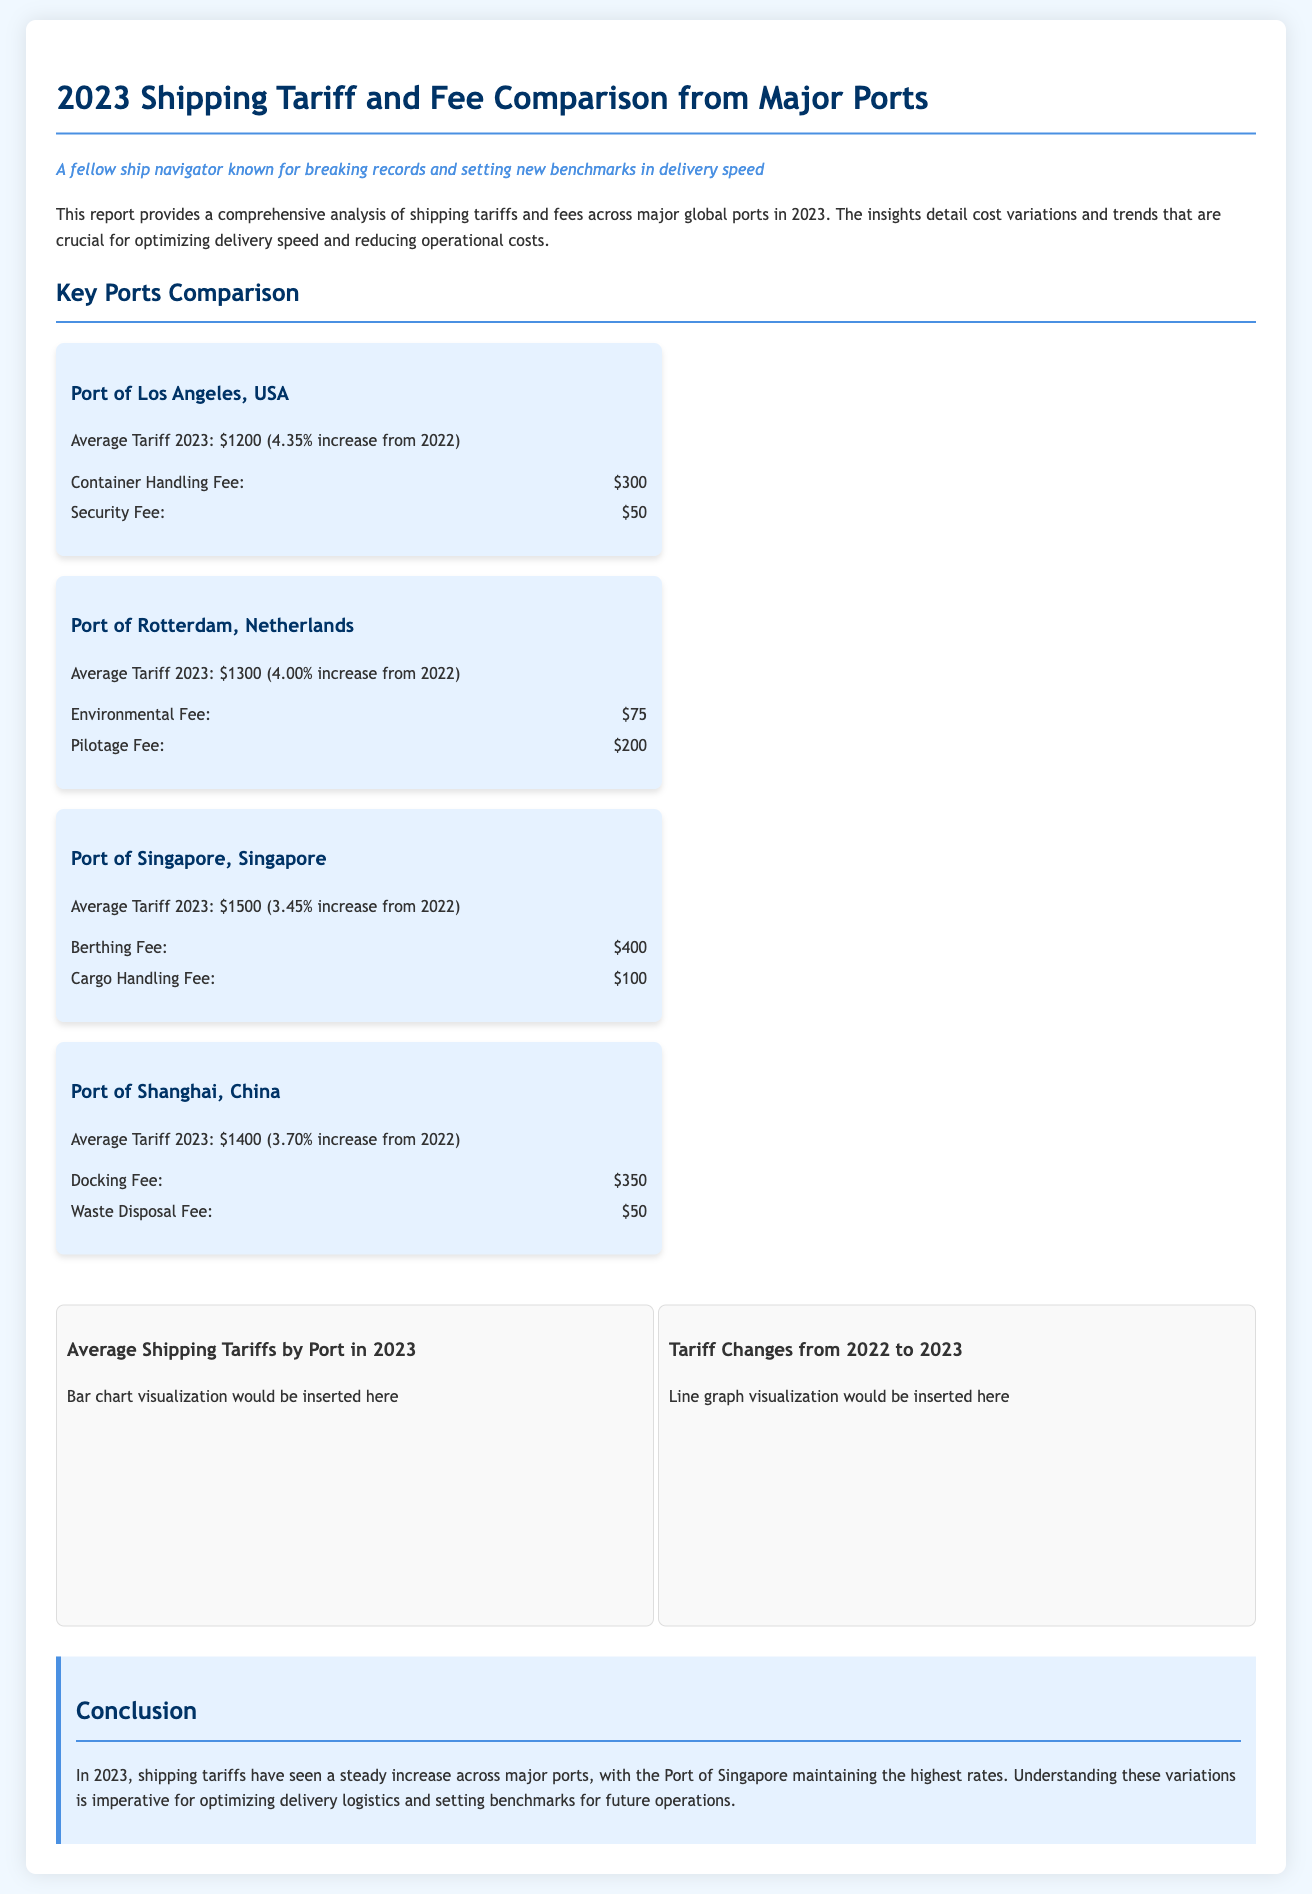What is the average tariff for the Port of Los Angeles in 2023? The average tariff for the Port of Los Angeles in 2023 is explicitly stated in the document.
Answer: $1200 What was the percentage increase in average tariff for the Port of Rotterdam from 2022 to 2023? The percentage increase from 2022 to 2023 for the Port of Rotterdam is mentioned as part of its tariff details.
Answer: 4.00% Which port had the highest average tariff in 2023? The document provides a comparison of average tariffs across ports, indicating which one is the highest.
Answer: Port of Singapore What is included in the Port of Shanghai's fees list? The fees list for Port of Shanghai outlines specific charges like docking and waste disposal fees for clarity.
Answer: Docking Fee and Waste Disposal Fee What visual aids are included in the report? The document describes two types of visual aids related to tariffs, providing insight into their nature and purpose.
Answer: Bar chart and line graph Which port had a 3.45% increase in average tariff? This specific increase is noted in the section detailing the ports and their tariffs.
Answer: Port of Singapore What is the conclusion about shipping tariffs in 2023? The conclusion summarizes the overall trends and observations regarding shipping tariffs within the report.
Answer: Increasing across major ports 